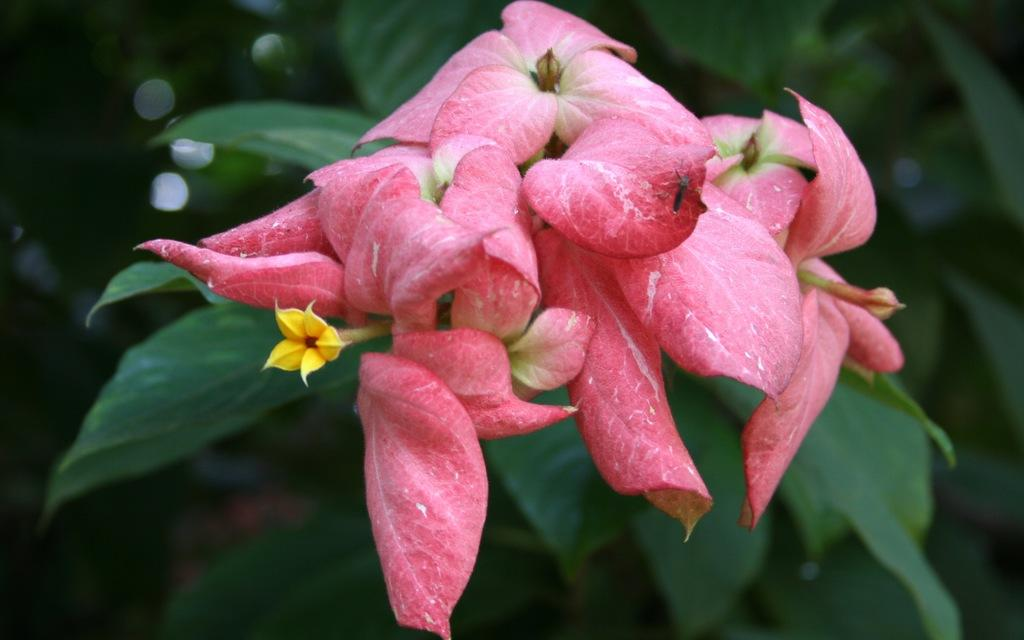What type of plant life is visible in the image? There are flowers in the image. What else can be seen in the background of the image? There are leaves in the background of the image. How would you describe the background of the image? The background of the image is blurry. What type of lamp is present in the image? There is no lamp present in the image. What part of the flower is responsible for creating friction? Flowers do not create friction, so this question cannot be answered based on the image. 